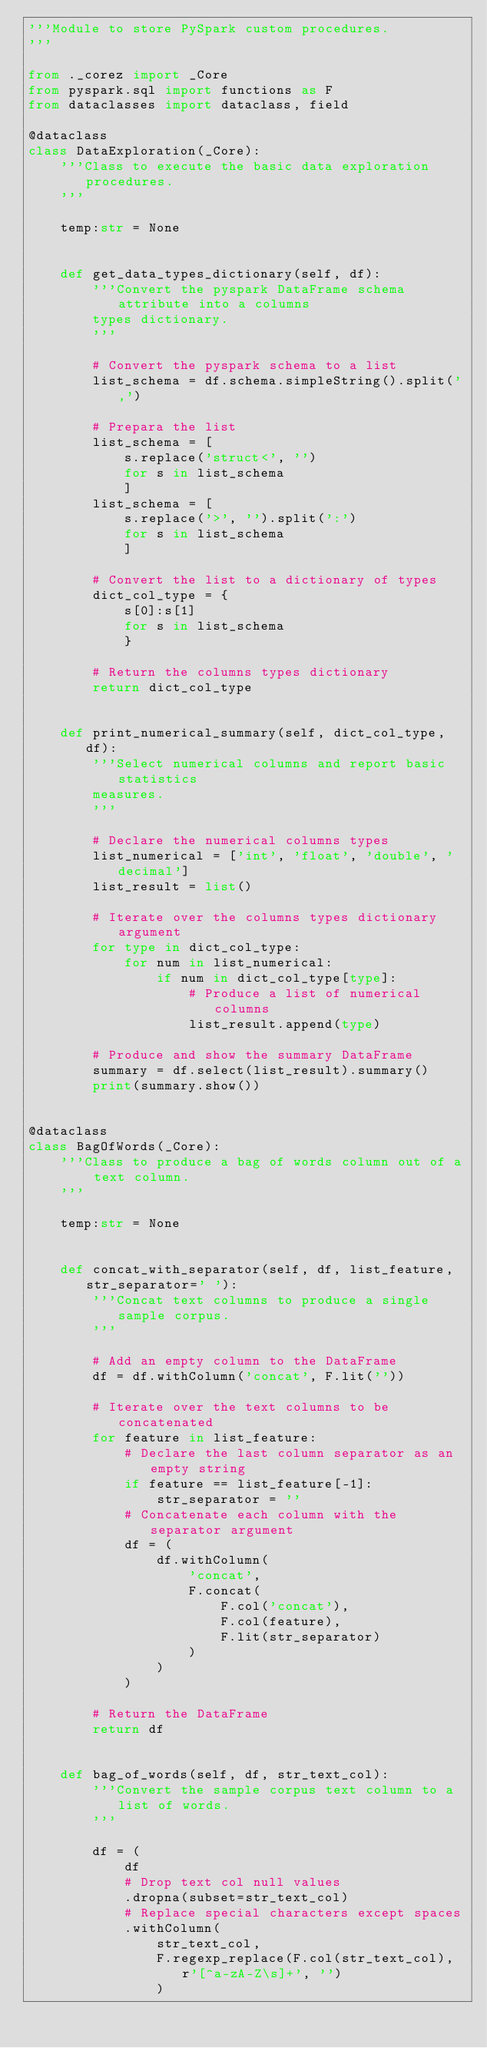Convert code to text. <code><loc_0><loc_0><loc_500><loc_500><_Python_>'''Module to store PySpark custom procedures.
'''

from ._corez import _Core
from pyspark.sql import functions as F
from dataclasses import dataclass, field

@dataclass
class DataExploration(_Core):
    '''Class to execute the basic data exploration procedures.
    '''

    temp:str = None


    def get_data_types_dictionary(self, df):
        '''Convert the pyspark DataFrame schema attribute into a columns
        types dictionary.
        '''

        # Convert the pyspark schema to a list
        list_schema = df.schema.simpleString().split(',')

        # Prepara the list
        list_schema = [
            s.replace('struct<', '')
            for s in list_schema
            ]
        list_schema = [
            s.replace('>', '').split(':')
            for s in list_schema
            ]

        # Convert the list to a dictionary of types
        dict_col_type = {
            s[0]:s[1]
            for s in list_schema
            }

        # Return the columns types dictionary
        return dict_col_type
        
    
    def print_numerical_summary(self, dict_col_type, df):
        '''Select numerical columns and report basic statistics
        measures.
        '''
        
        # Declare the numerical columns types
        list_numerical = ['int', 'float', 'double', 'decimal']
        list_result = list()

        # Iterate over the columns types dictionary argument
        for type in dict_col_type:
            for num in list_numerical:
                if num in dict_col_type[type]:
                    # Produce a list of numerical columns
                    list_result.append(type)
        
        # Produce and show the summary DataFrame
        summary = df.select(list_result).summary()
        print(summary.show())


@dataclass
class BagOfWords(_Core):
    '''Class to produce a bag of words column out of a text column.
    '''

    temp:str = None


    def concat_with_separator(self, df, list_feature, str_separator=' '):
        '''Concat text columns to produce a single sample corpus.
        '''

        # Add an empty column to the DataFrame
        df = df.withColumn('concat', F.lit(''))

        # Iterate over the text columns to be concatenated
        for feature in list_feature:
            # Declare the last column separator as an empty string
            if feature == list_feature[-1]:
                str_separator = ''
            # Concatenate each column with the separator argument
            df = (
                df.withColumn(
                    'concat',
                    F.concat(
                        F.col('concat'),
                        F.col(feature),
                        F.lit(str_separator)
                    )
                )
            )

        # Return the DataFrame
        return df
    

    def bag_of_words(self, df, str_text_col):
        '''Convert the sample corpus text column to a list of words.
        '''

        df = (
            df
            # Drop text col null values
            .dropna(subset=str_text_col)
            # Replace special characters except spaces
            .withColumn(
                str_text_col,
                F.regexp_replace(F.col(str_text_col), r'[^a-zA-Z\s]+', '')
                )</code> 